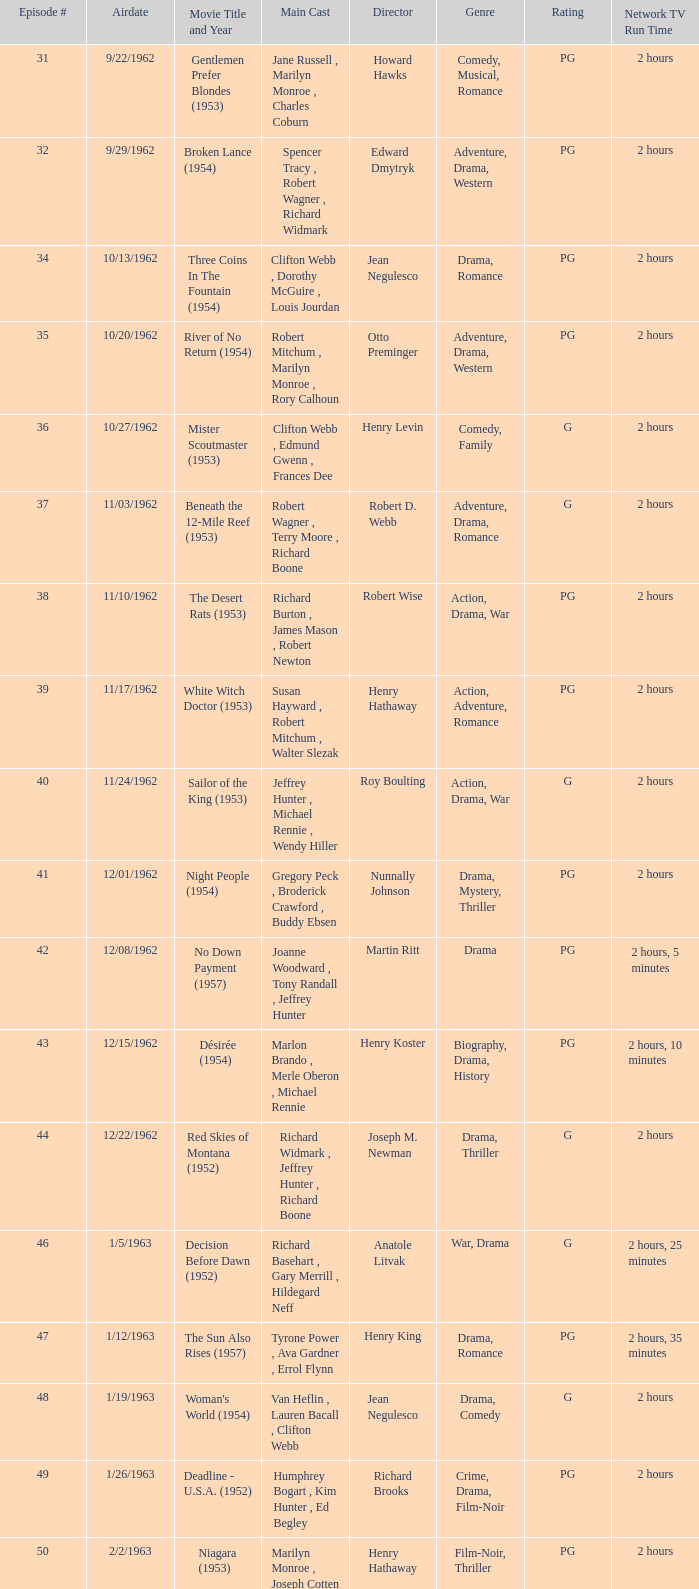How many runtimes does episode 53 have? 1.0. 